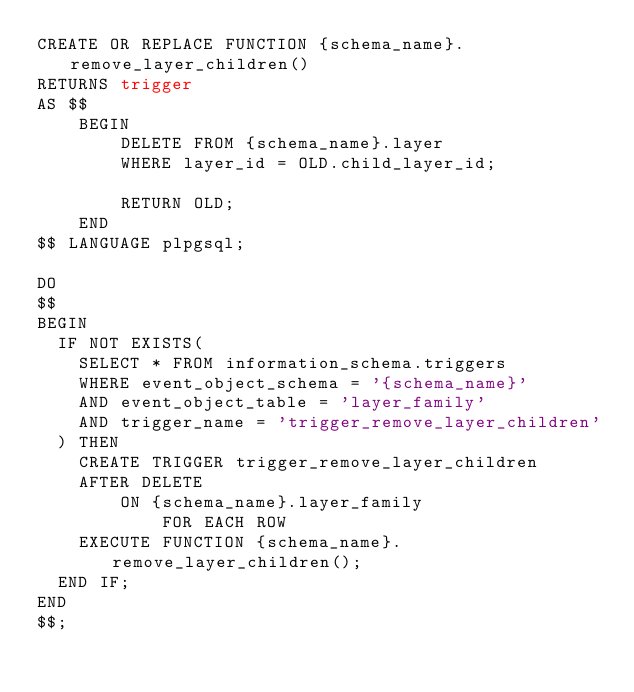Convert code to text. <code><loc_0><loc_0><loc_500><loc_500><_SQL_>CREATE OR REPLACE FUNCTION {schema_name}.remove_layer_children()
RETURNS trigger
AS $$
    BEGIN
        DELETE FROM {schema_name}.layer
        WHERE layer_id = OLD.child_layer_id;

        RETURN OLD;
    END
$$ LANGUAGE plpgsql;

DO
$$
BEGIN
	IF NOT EXISTS(
		SELECT * FROM information_schema.triggers
		WHERE event_object_schema = '{schema_name}'
		AND event_object_table = 'layer_family'
		AND trigger_name = 'trigger_remove_layer_children'
	) THEN
		CREATE TRIGGER trigger_remove_layer_children
		AFTER DELETE
		    ON {schema_name}.layer_family
            FOR EACH ROW
		EXECUTE FUNCTION {schema_name}.remove_layer_children();
	END IF;
END
$$;</code> 